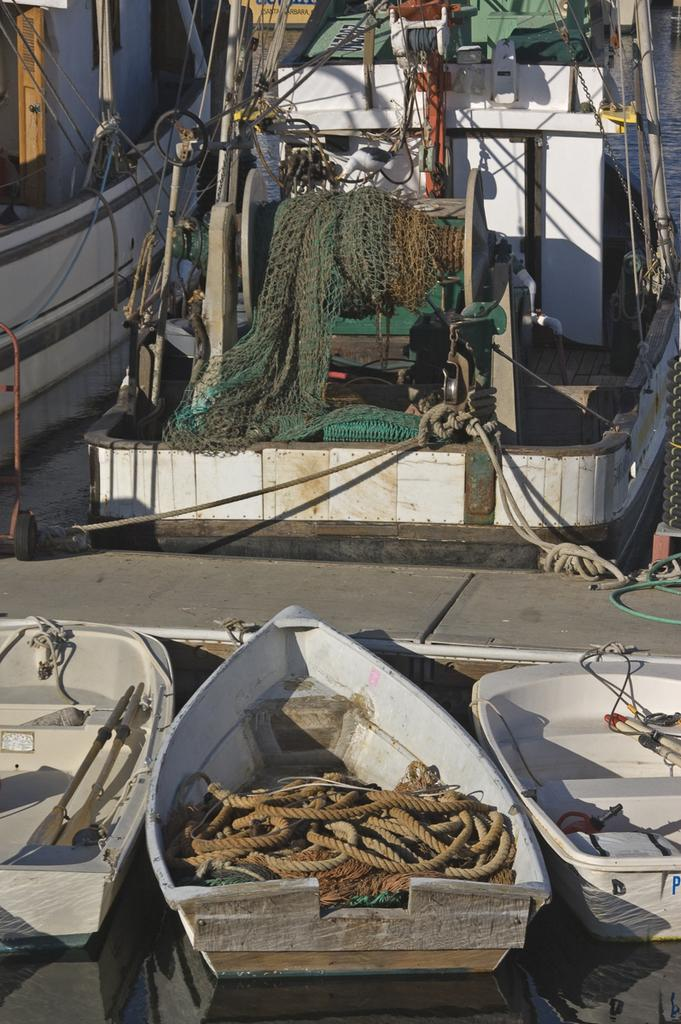What is the main subject in the center of the image? There is a boat in the center of the image. What materials can be seen in the image? Rope and wire are present in the image. What natural element is visible in the image? Water is visible at the top right corner of the image. Where is the door located in the image? A door is present at the top left corner of the image. Can you tell me how many donkeys are pulling the boat in the image? There are no donkeys present in the image; the boat is not being pulled by any animals. What type of adjustment can be seen on the vessel in the image? There is no vessel present in the image, only a boat. 